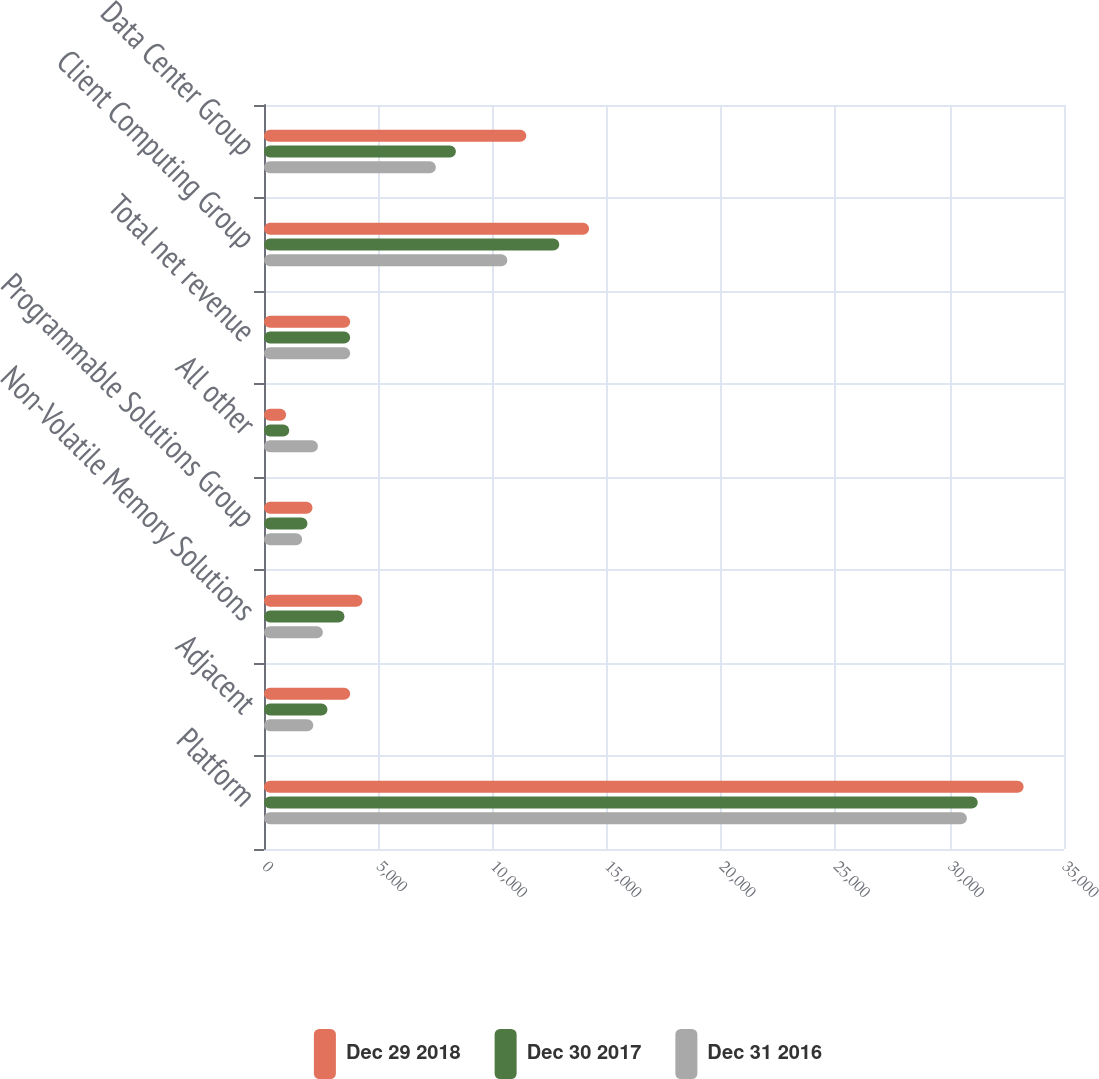Convert chart. <chart><loc_0><loc_0><loc_500><loc_500><stacked_bar_chart><ecel><fcel>Platform<fcel>Adjacent<fcel>Non-Volatile Memory Solutions<fcel>Programmable Solutions Group<fcel>All other<fcel>Total net revenue<fcel>Client Computing Group<fcel>Data Center Group<nl><fcel>Dec 29 2018<fcel>33234<fcel>3770<fcel>4307<fcel>2123<fcel>968<fcel>3770<fcel>14222<fcel>11476<nl><fcel>Dec 30 2017<fcel>31226<fcel>2777<fcel>3520<fcel>1902<fcel>1103<fcel>3770<fcel>12919<fcel>8395<nl><fcel>Dec 31 2016<fcel>30751<fcel>2157<fcel>2576<fcel>1669<fcel>2360<fcel>3770<fcel>10646<fcel>7520<nl></chart> 